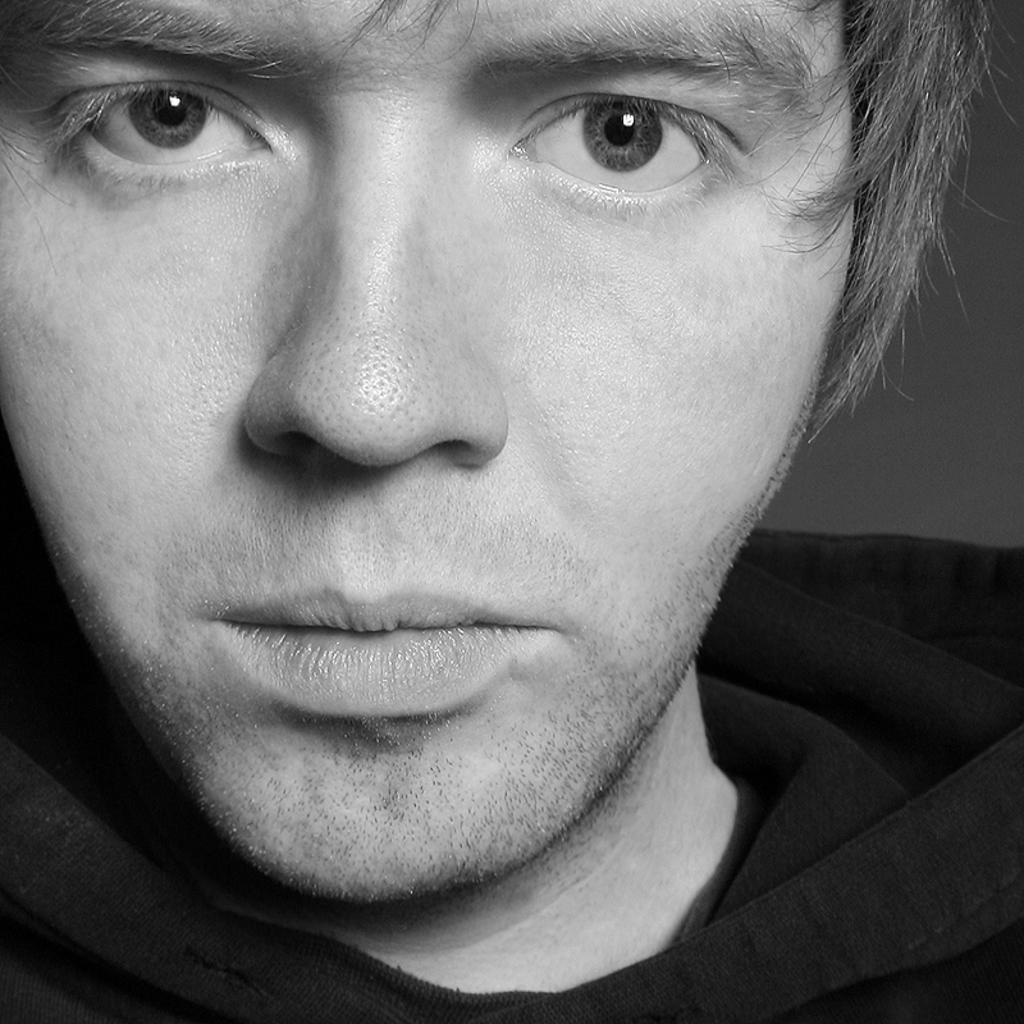What is the color scheme of the image? The image is black and white. Can you describe the main subject in the image? There is a person in the image. What is the person doing in the image? The person is looking at a picture. What news is the person reading from their stomach in the image? There is no news or stomach present in the image; it features a person looking at a picture. 